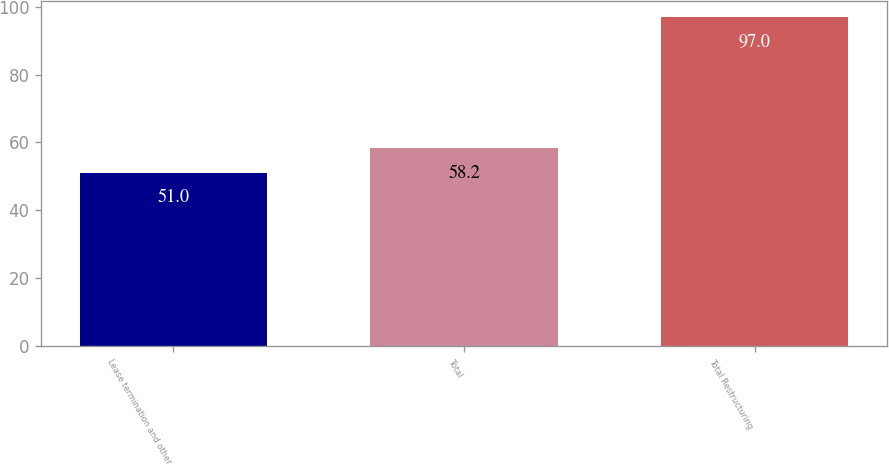<chart> <loc_0><loc_0><loc_500><loc_500><bar_chart><fcel>Lease termination and other<fcel>Total<fcel>Total Restructuring<nl><fcel>51<fcel>58.2<fcel>97<nl></chart> 